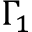Convert formula to latex. <formula><loc_0><loc_0><loc_500><loc_500>\Gamma _ { 1 }</formula> 